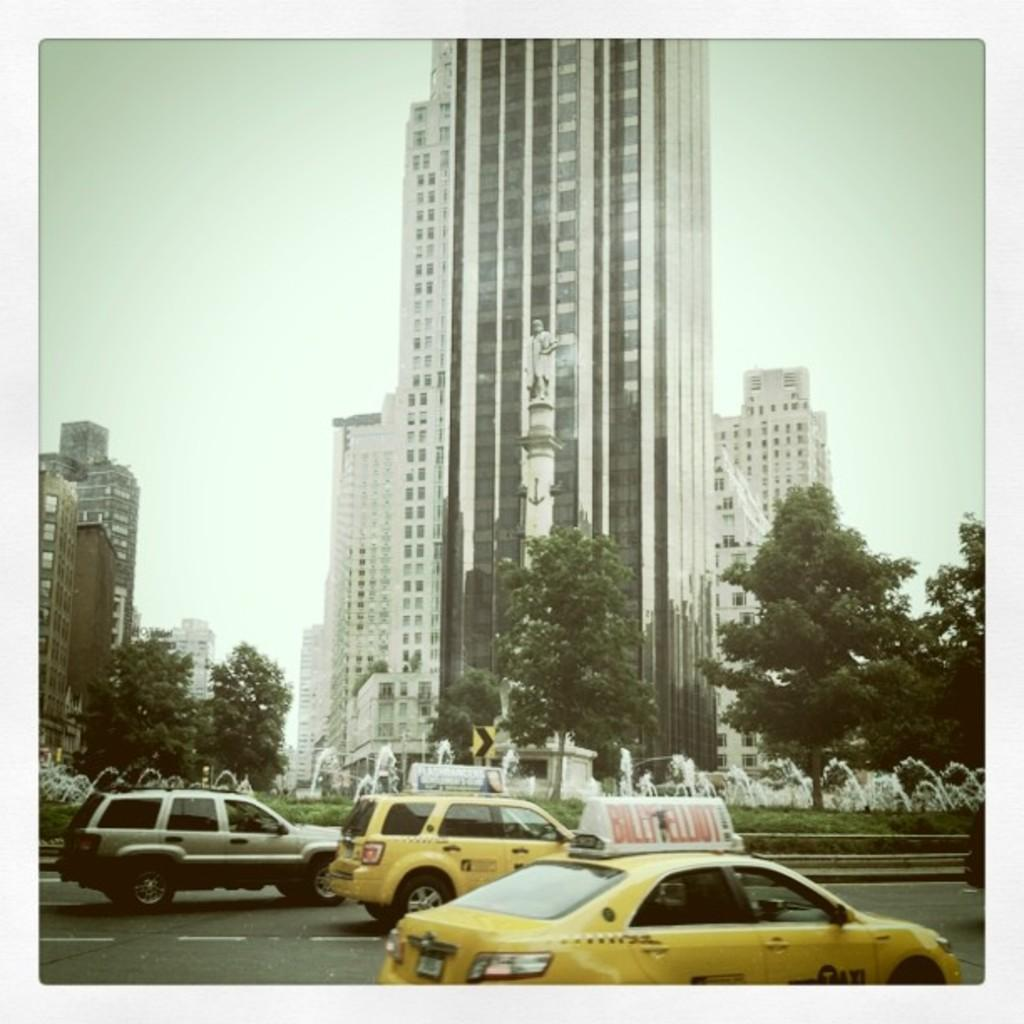<image>
Give a short and clear explanation of the subsequent image. a yellow car with the word taxi on the side is on the street 